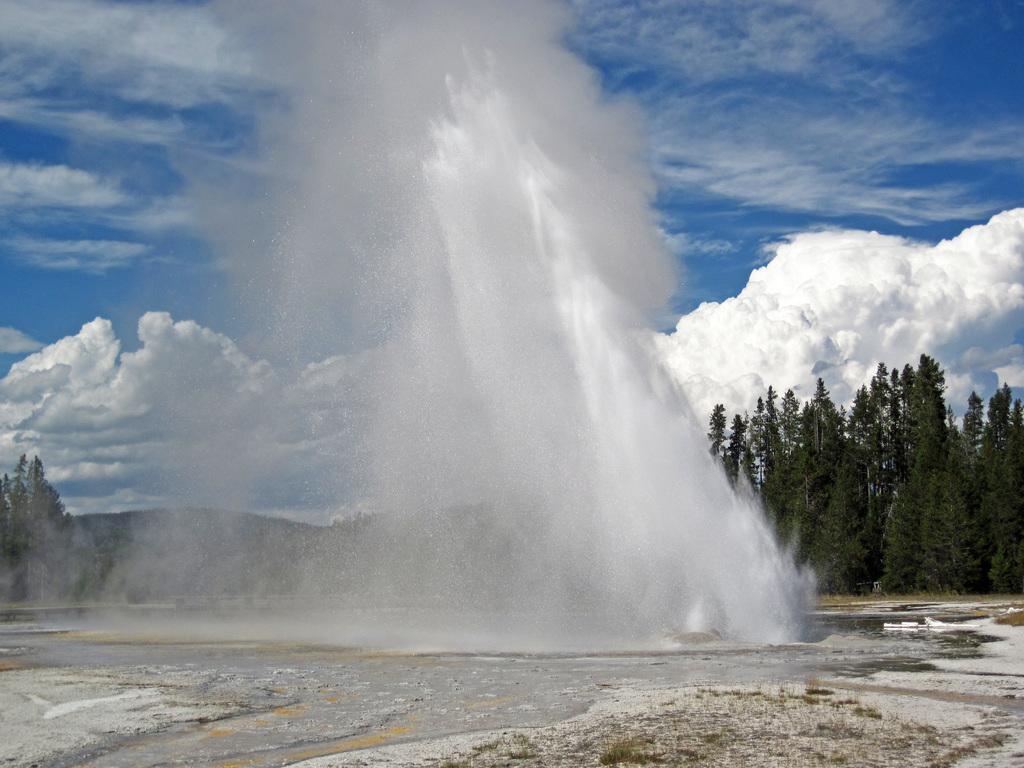In one or two sentences, can you explain what this image depicts? At the bottom of this image, there is water and snow surface. In the background, there are trees, snowfall and there are clouds in the blue sky. 